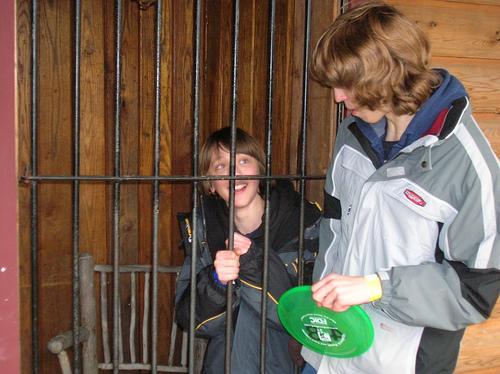Is there a chair in the picture?
Give a very brief answer. Yes. What is the tall boy holding in his right hand?
Write a very short answer. Frisbee. What is the boy pretending to be in?
Give a very brief answer. Jail. Does this man have long hair?
Write a very short answer. Yes. What is on the man's left hand?
Quick response, please. Frisbee. 